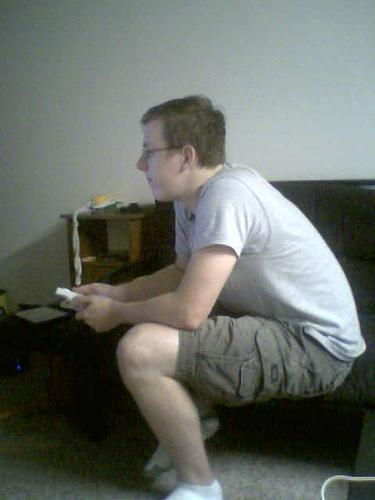What type of furniture is the boy sitting on?

Choices:
A) bench
B) sectional
C) chaise
D) futon futon 